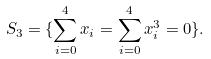Convert formula to latex. <formula><loc_0><loc_0><loc_500><loc_500>S _ { 3 } = \{ \sum _ { i = 0 } ^ { 4 } x _ { i } = \sum _ { i = 0 } ^ { 4 } x _ { i } ^ { 3 } = 0 \} .</formula> 